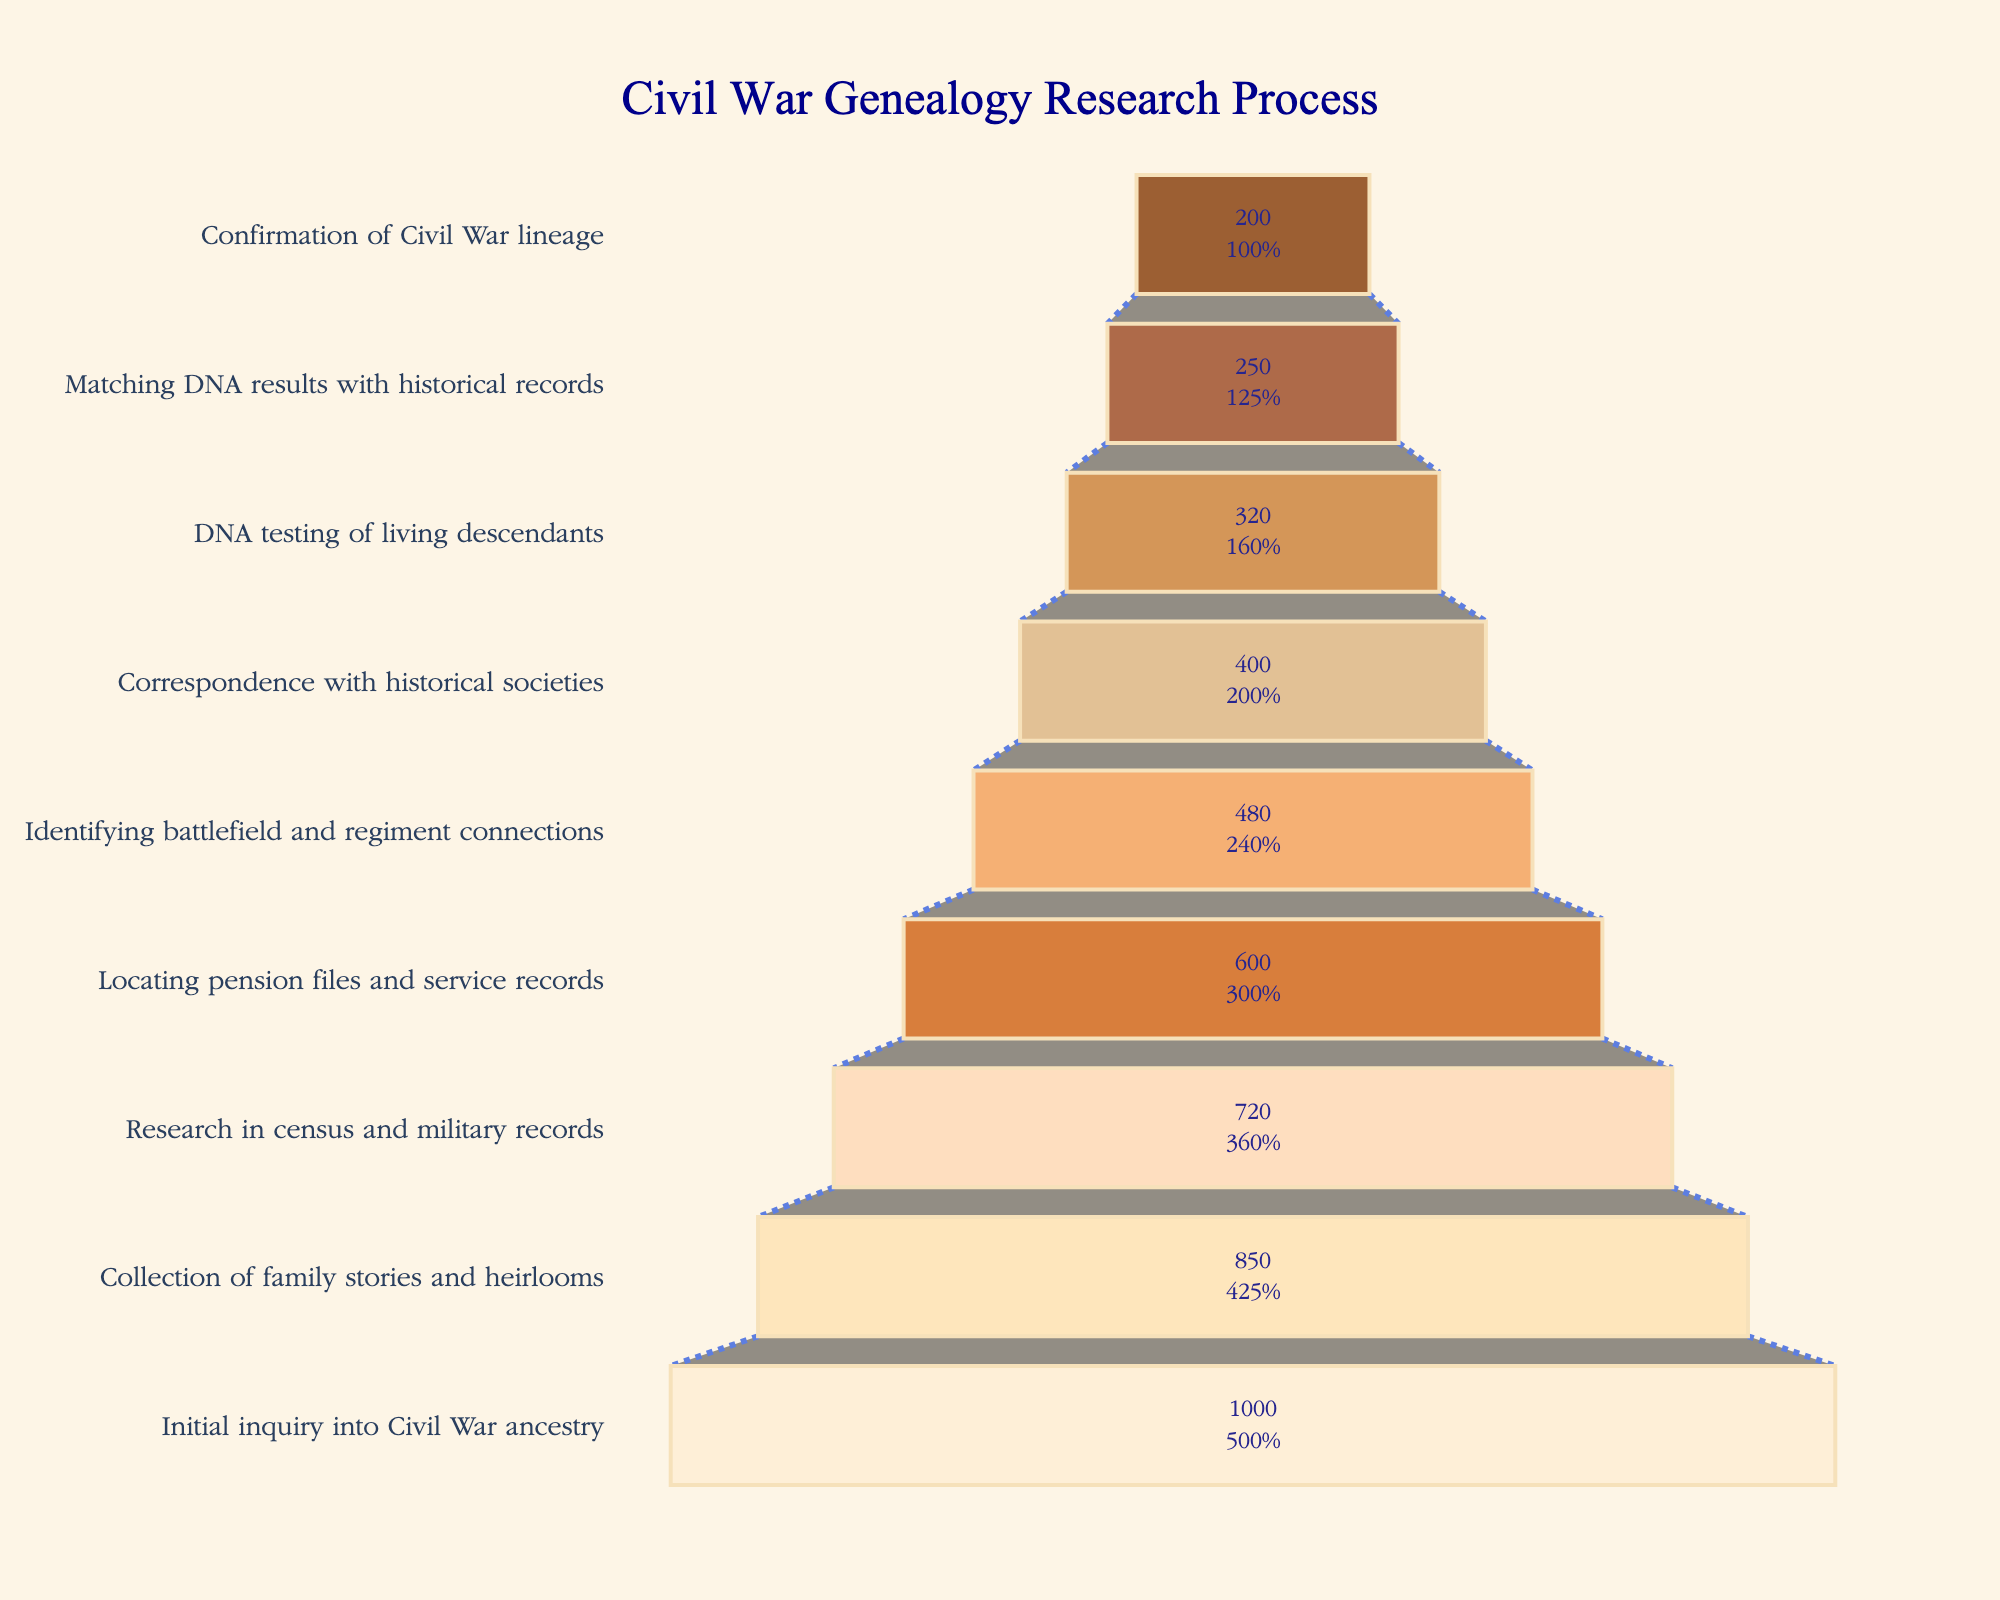How many families reached the final stage of confirming their Civil War lineage? To find the number of families at the final stage, refer to the "Confirmation of Civil War lineage" category in the funnel chart.
Answer: 200 What percentage of families completed the initial inquiry stage compared to those who confirmed their Civil War lineage? Compare the numbers at the "Initial inquiry into Civil War ancestry" (1000) and "Confirmation of Civil War lineage" (200) stages. Percentage = (200/1000) * 100 = 20%.
Answer: 20% Which stage had the most significant drop-off in the number of families? Identify the stages with the largest numerical difference between adjacent stages by comparing numbers between each pair. The largest difference is between "Initial inquiry into Civil War ancestry" (1000) and "Collection of family stories and heirlooms" (850), with a drop-off of 150 families.
Answer: Between the first and second stages How many families continued to research after they located pension files and service records? To find this number, look at the number of families in the subsequent stage, "Identifying battlefield and regiment connections," which has 480 families.
Answer: 480 What is the total number of families that dropped out before reaching the DNA testing stage? To calculate this, sum up the differences between each stage before "DNA testing of living descendants": (1000 - 850) + (850 - 720) + (720 - 600) + (600 - 480) + (480 - 400) = 150 + 130 + 120 + 120 + 80 = 600.
Answer: 600 How does the number of families that reached the DNA testing stage compare to those who confirmed their lineage? Compare the numbers at the "DNA testing of living descendants" (320) and "Confirmation of Civil War lineage" (200) stages. Subtract the confirmed lineage number from the DNA testing number: 320 - 200 = 120.
Answer: 120 Which stages show less than 50% of the families making progress to the next stage? Calculate the percentage drop-off between each pair of adjacent stages and identify those with more than 50% dropout: (1000 to 850 is 15%), (850 to 720 is ~15.3%), (720 to 600 is ~16.7%), (600 to 480 is 20%), (480 to 400 is 16.7%), (400 to 320 is ~20%), (320 to 250 is ~21.9%), (250 to 200 is 20%). No stages had a drop-off of more than 50%.
Answer: None Between which two stages is the smallest number of families lost? Identify stages with the smallest numerical difference between adjacent stages: smallest difference is between "Correspondence with historical societies" (400) and "DNA testing of living descendants" (320), with a drop-off of 80.
Answer: Between correspondence and DNA testing What fraction of the original families confirmed their Civil War lineage? Determine the fraction of families that reached "Confirmation of Civil War lineage": 200 out of 1000. The fraction is 200/1000 = 1/5.
Answer: 1/5 What is the percentage increase from the stage of matching DNA results to the final confirmation of Civil War lineage? Calculate the percentage decrease, not an increase, since the final stage always has fewer or equal numbers. The stages in question are "Matching DNA results with historical records" (250) to "Confirmation of Civil War lineage" (200). Hence, the percentage decrease is [(250 - 200) / 250] * 100 = 20%.
Answer: 20% decrease 